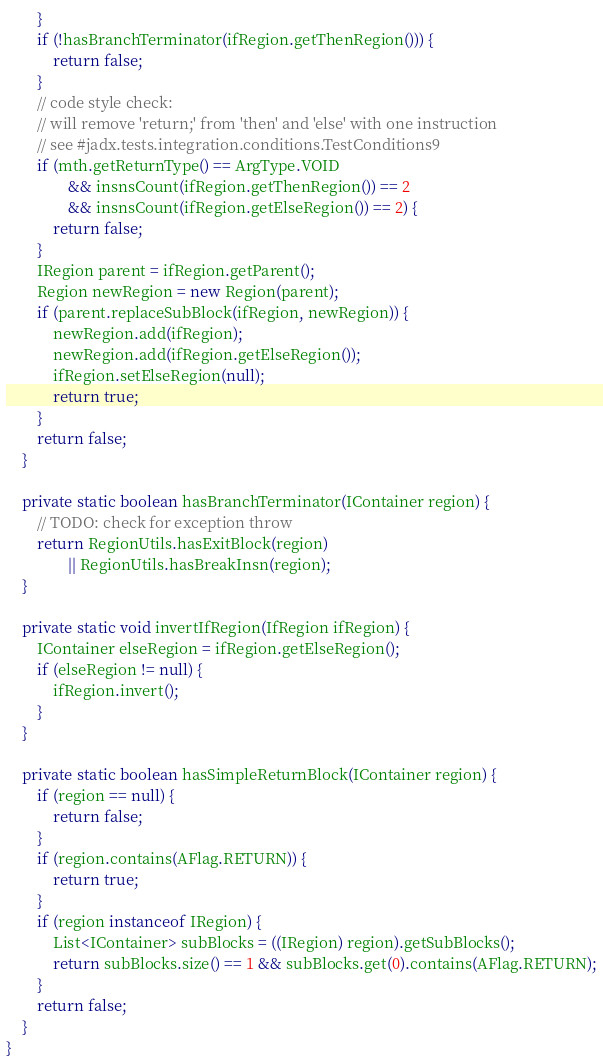<code> <loc_0><loc_0><loc_500><loc_500><_Java_>		}
		if (!hasBranchTerminator(ifRegion.getThenRegion())) {
			return false;
		}
		// code style check:
		// will remove 'return;' from 'then' and 'else' with one instruction
		// see #jadx.tests.integration.conditions.TestConditions9
		if (mth.getReturnType() == ArgType.VOID
				&& insnsCount(ifRegion.getThenRegion()) == 2
				&& insnsCount(ifRegion.getElseRegion()) == 2) {
			return false;
		}
		IRegion parent = ifRegion.getParent();
		Region newRegion = new Region(parent);
		if (parent.replaceSubBlock(ifRegion, newRegion)) {
			newRegion.add(ifRegion);
			newRegion.add(ifRegion.getElseRegion());
			ifRegion.setElseRegion(null);
			return true;
		}
		return false;
	}

	private static boolean hasBranchTerminator(IContainer region) {
		// TODO: check for exception throw
		return RegionUtils.hasExitBlock(region)
				|| RegionUtils.hasBreakInsn(region);
	}

	private static void invertIfRegion(IfRegion ifRegion) {
		IContainer elseRegion = ifRegion.getElseRegion();
		if (elseRegion != null) {
			ifRegion.invert();
		}
	}

	private static boolean hasSimpleReturnBlock(IContainer region) {
		if (region == null) {
			return false;
		}
		if (region.contains(AFlag.RETURN)) {
			return true;
		}
		if (region instanceof IRegion) {
			List<IContainer> subBlocks = ((IRegion) region).getSubBlocks();
			return subBlocks.size() == 1 && subBlocks.get(0).contains(AFlag.RETURN);
		}
		return false;
	}
}
</code> 